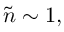<formula> <loc_0><loc_0><loc_500><loc_500>\tilde { n } \sim 1 ,</formula> 